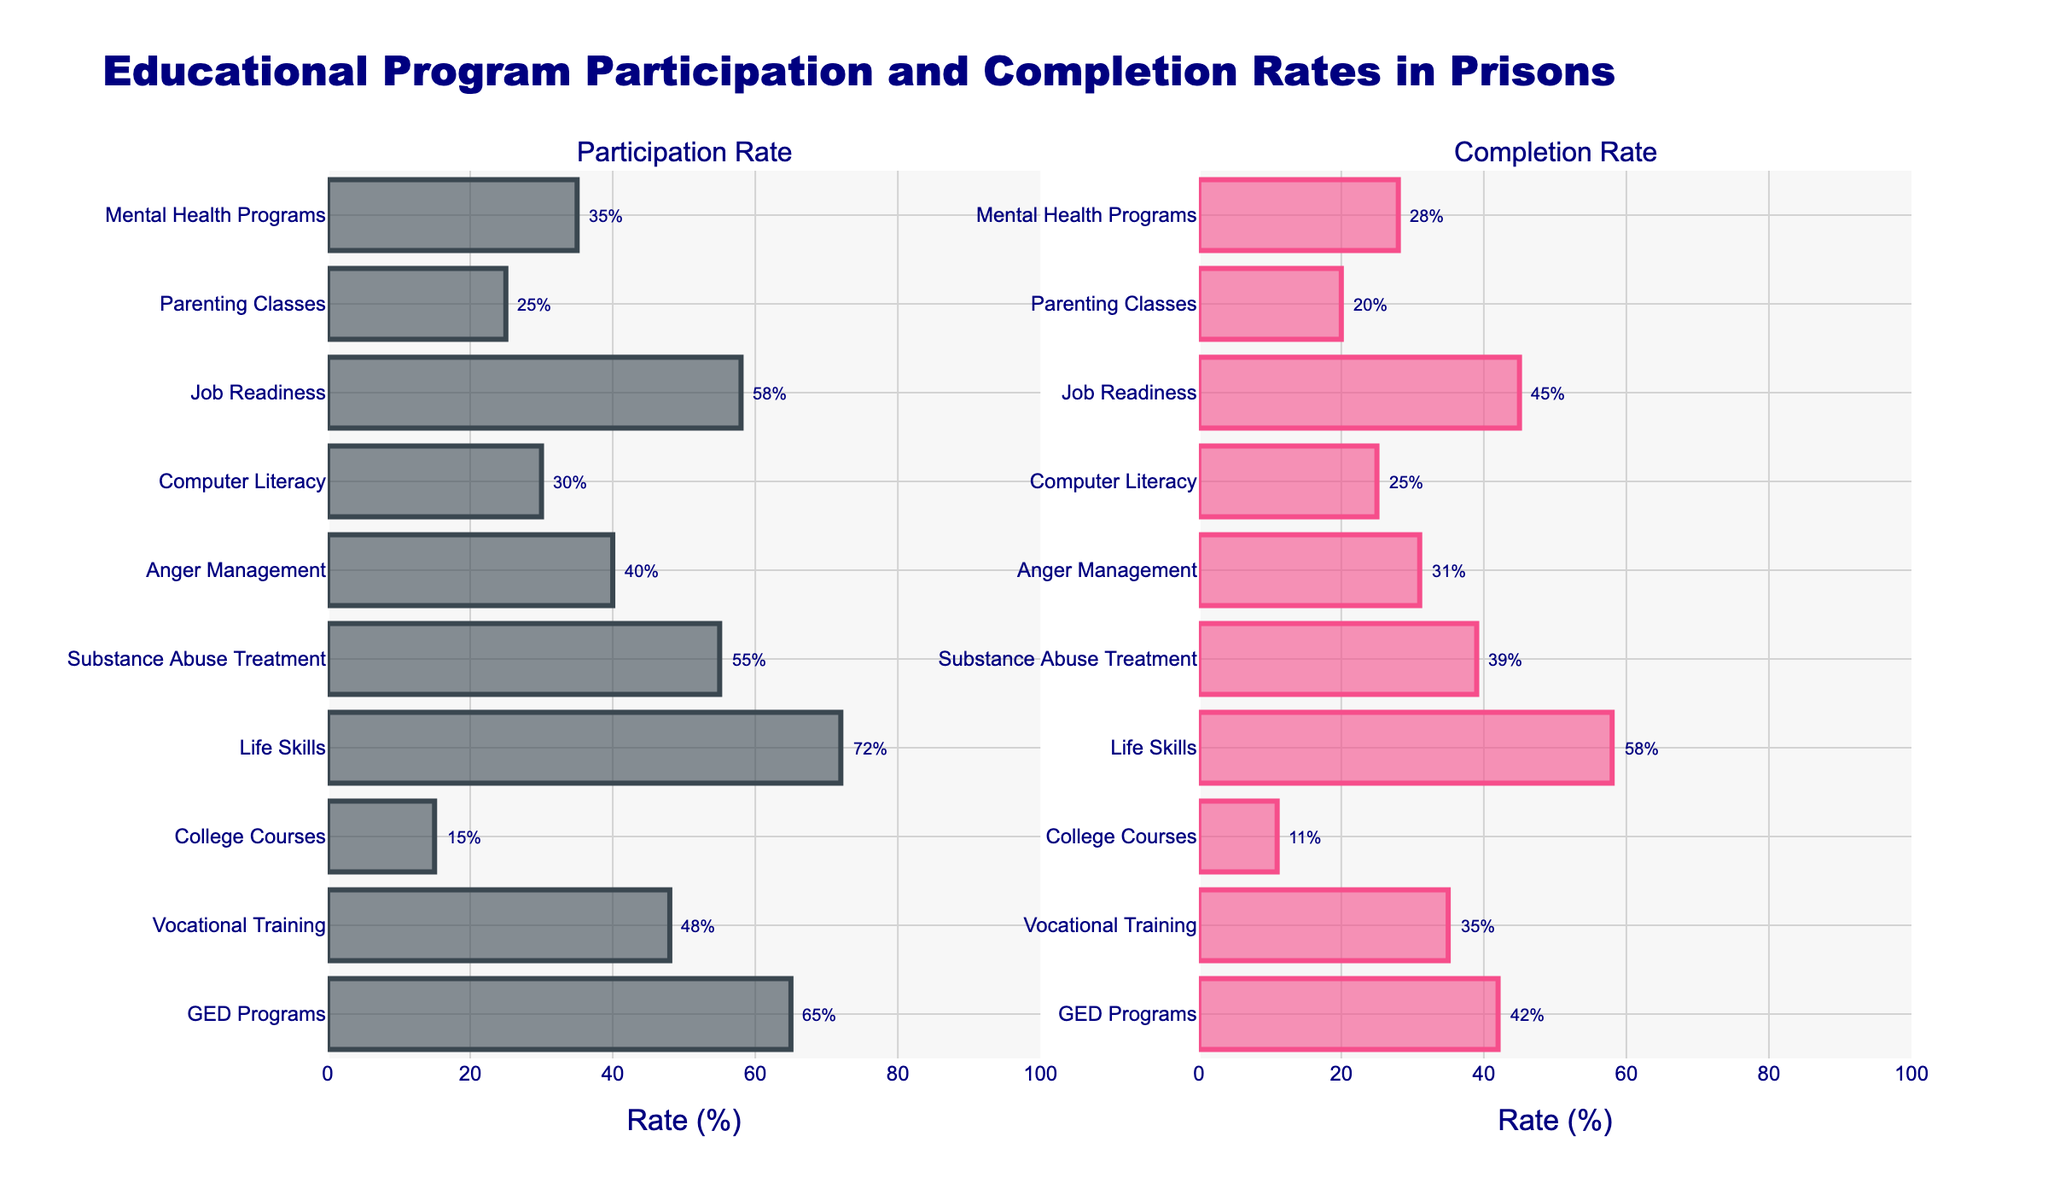Which program has the highest participation rate? By looking at the left bar chart (Participation Rate), Life Skills has the tallest bar, indicating the highest participation rate.
Answer: Life Skills Which program has the lowest completion rate? By examining the right bar chart (Completion Rate), College Courses has the shortest bar, indicating the lowest completion rate.
Answer: College Courses What is the difference between the participation rate and completion rate for GED Programs? Look at the participation and completion rates for GED Programs. The Participation Rate is 65% and the Completion Rate is 42%. The difference is 65% - 42%.
Answer: 23% Which programs have a completion rate greater than 40%? By scanning the right bar chart, identify bars higher than the 40% mark. Life Skills, Job Readiness, and GED Programs all have completion rates above 40%.
Answer: Life Skills, Job Readiness, GED Programs How does the participation rate for Substance Abuse Treatment compare to Computer Literacy? Check the left bar chart and compare the lengths of the bars for Substance Abuse Treatment (55%) and Computer Literacy (30%). Substance Abuse Treatment's bar is longer, indicating a higher participation rate.
Answer: Higher What's the average completion rate for the programs listed? Sum all the completion rates and divide by the number of programs: (42 + 35 + 11 + 58 + 39 + 31 + 25 + 45 + 20 + 28)/10.
Answer: 33.4% Which program has the closest completion rate to its participation rate? Compare the participation and completion rates for all programs. Job Readiness has participation (58%) and completion (45%) rates that are closest in value.
Answer: Job Readiness Which programs have a higher participation rate than College Courses but lower than Vocational Training? Identify the Participation Rates: College Courses (15%), Vocational Training (48%). The programs that fall in between are Computer Literacy (30%) and Anger Management (40%).
Answer: Computer Literacy, Anger Management By how much does the completion rate for Parenting Classes fall short of the participation rate? Look at the rates for Parenting Classes: Participation Rate is 25%, Completion Rate is 20%. The shortfall is 25% - 20%.
Answer: 5% What is the overall trend between participation and completion rates across all programs? Generally, bars in the left chart (Participation Rate) are taller than those in the right chart (Completion Rate), indicating that completion rates are consistently lower than participation rates across all programs.
Answer: Completion rates are consistently lower than participation rates 